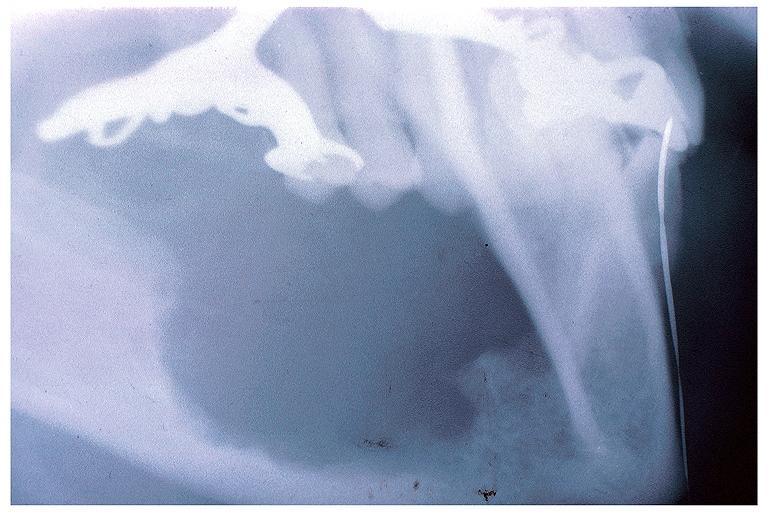does this image show intraosseous mucoepidermoid carcinoma?
Answer the question using a single word or phrase. Yes 